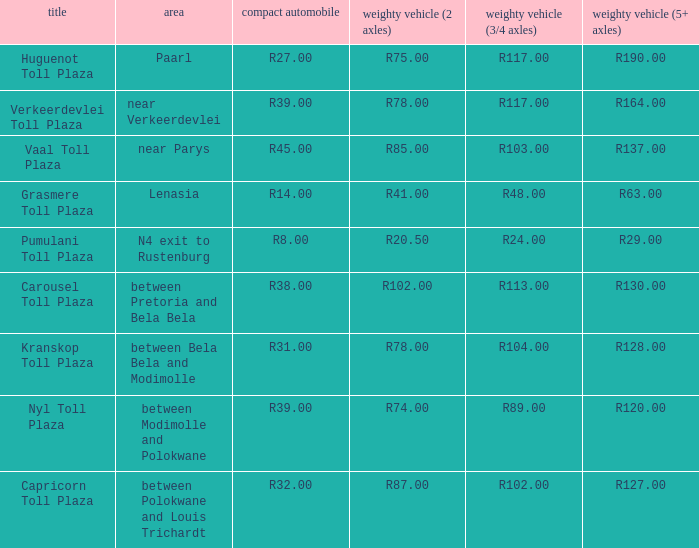What is the name of the plaza where the toll for heavy vehicles with 2 axles is r87.00? Capricorn Toll Plaza. 